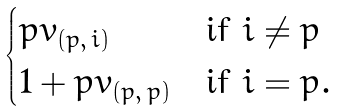<formula> <loc_0><loc_0><loc_500><loc_500>\begin{cases} p v _ { ( p , \, i ) } & \text {if } i \not = p \\ 1 + p v _ { ( p , \, p ) } & \text {if } i = p . \end{cases}</formula> 